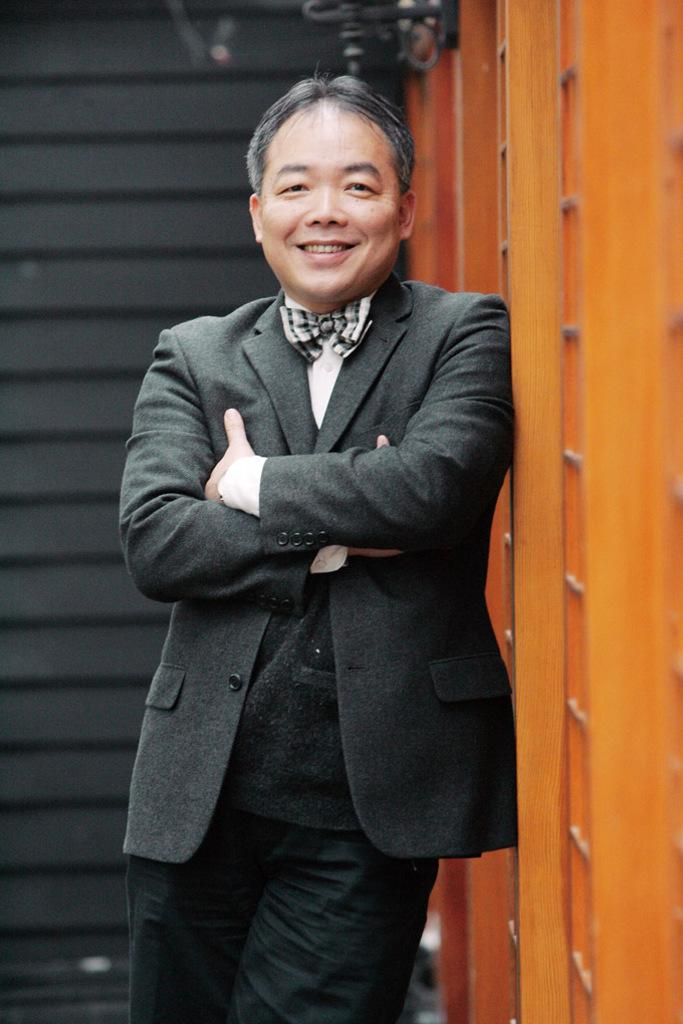What is the main subject of the image? There is a person in the image. What is the person wearing on their upper body? The person is wearing a black color blazer and a white color shirt. What type of wall is visible in the image? There is a wooden wall in the image, and it is in brown color. What is the background color in the image? The background color in the image is black. What type of pencil can be seen in the person's hand in the image? There is no pencil visible in the person's hand or anywhere else in the image. 